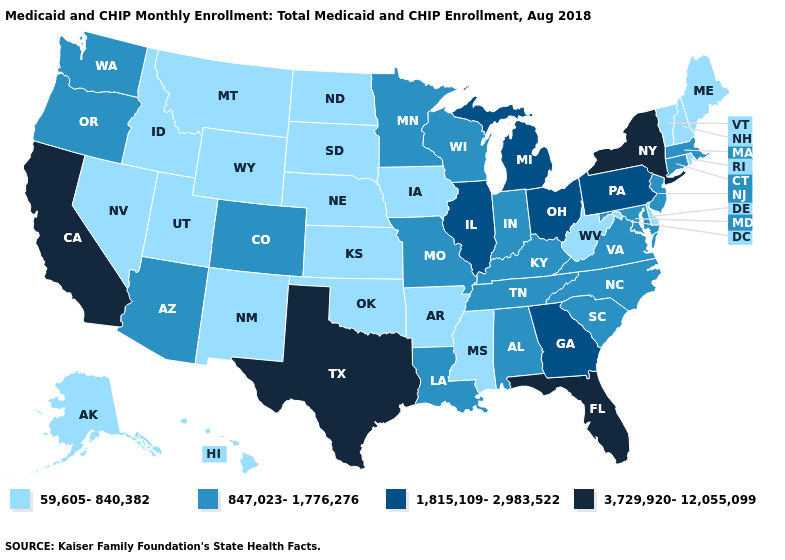What is the value of Georgia?
Quick response, please. 1,815,109-2,983,522. What is the highest value in the USA?
Keep it brief. 3,729,920-12,055,099. Does Kentucky have a lower value than Pennsylvania?
Concise answer only. Yes. Among the states that border North Dakota , does Montana have the lowest value?
Short answer required. Yes. Does North Dakota have a lower value than Maine?
Give a very brief answer. No. Does Washington have the same value as North Carolina?
Be succinct. Yes. How many symbols are there in the legend?
Give a very brief answer. 4. Does Arkansas have the lowest value in the South?
Answer briefly. Yes. Does Wisconsin have the lowest value in the MidWest?
Answer briefly. No. What is the lowest value in states that border Iowa?
Concise answer only. 59,605-840,382. Name the states that have a value in the range 1,815,109-2,983,522?
Give a very brief answer. Georgia, Illinois, Michigan, Ohio, Pennsylvania. Among the states that border Missouri , which have the highest value?
Give a very brief answer. Illinois. Name the states that have a value in the range 59,605-840,382?
Keep it brief. Alaska, Arkansas, Delaware, Hawaii, Idaho, Iowa, Kansas, Maine, Mississippi, Montana, Nebraska, Nevada, New Hampshire, New Mexico, North Dakota, Oklahoma, Rhode Island, South Dakota, Utah, Vermont, West Virginia, Wyoming. Among the states that border North Dakota , which have the lowest value?
Quick response, please. Montana, South Dakota. Does Virginia have a higher value than Nevada?
Answer briefly. Yes. 